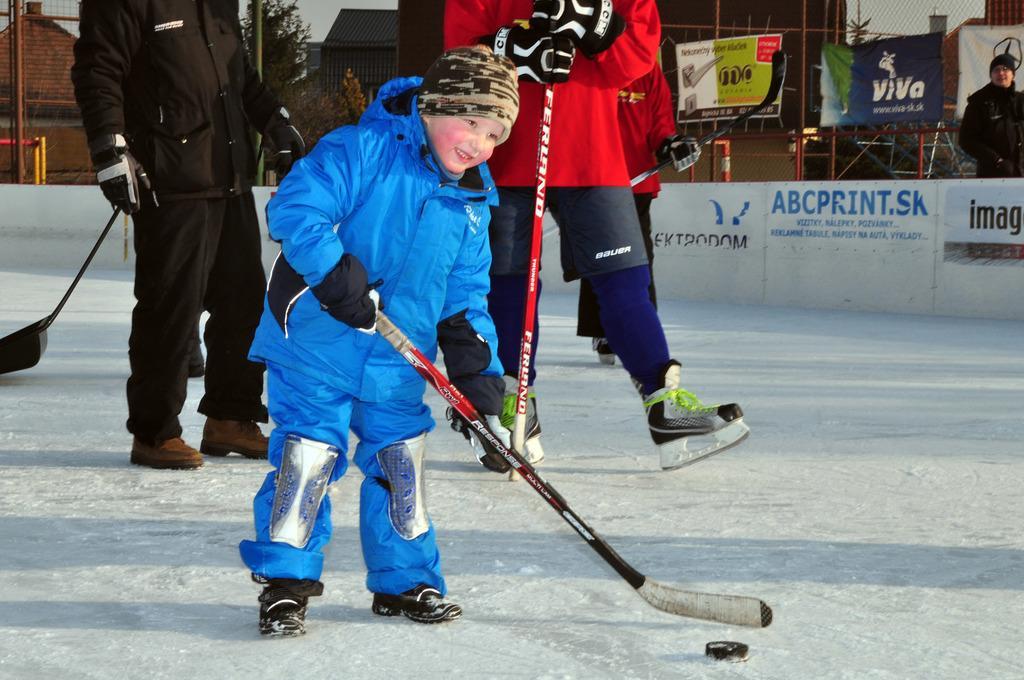In one or two sentences, can you explain what this image depicts? In this image I can see a boy is holding the hockey bat. He is wearing the blue color coat, trouser. At the back side there are few people standing, on the right side there are boats on the iron frame. 